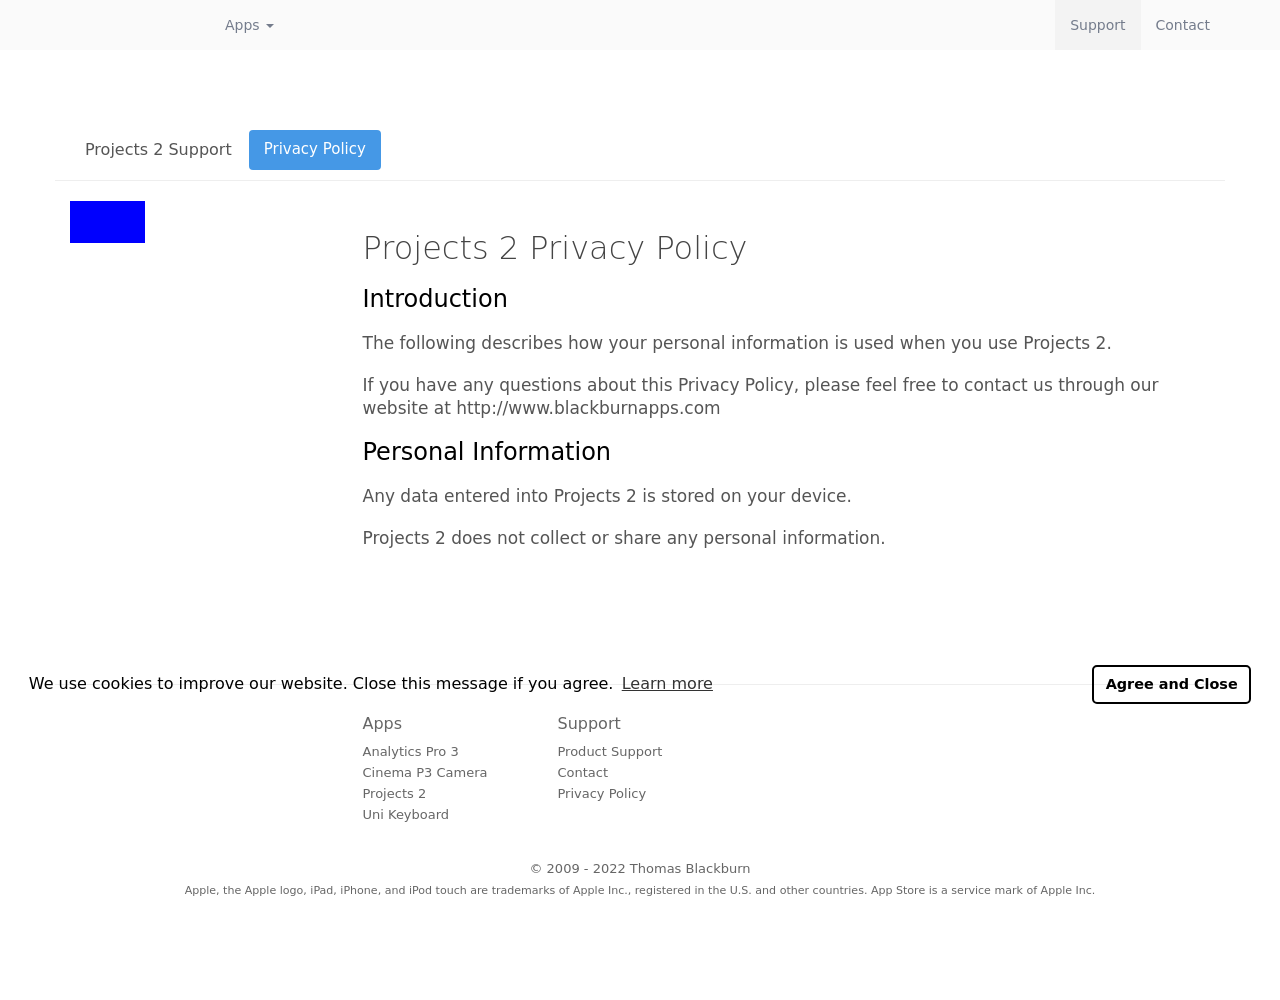What type of user might find the features shown in the image beneficial? Features shown in the image, such as the privacy policy and personal data storage, are particularly beneficial for users who are concerned about data security and privacy. This can include professionals handling sensitive information, individuals who prefer offline applications to ensure data safety, and tech-savvy users who prioritize control over their digital footprint. 